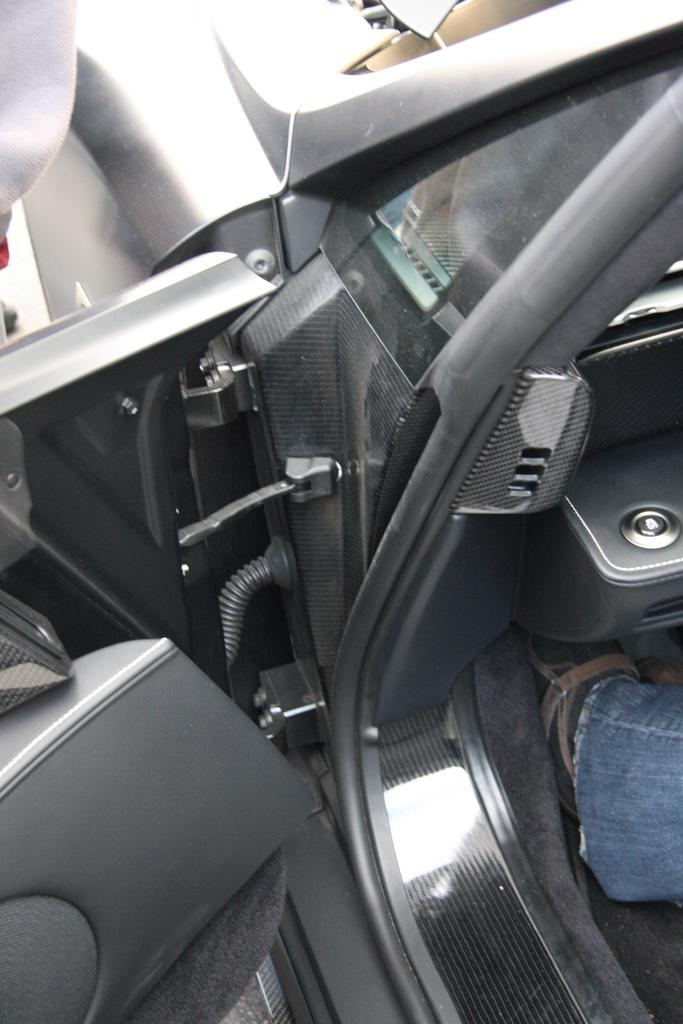What is the position of the car door in the image? The car door is opened in the image. Can you describe the presence of a person in the image? A person's leg is visible inside the car, and there is also a person standing on the left side of the image. What type of street is visible in the image? There is no street visible in the image; it only shows a car door and a person's leg inside the car. What fact can be determined about the car's speed from the image? The image does not provide any information about the car's speed, as it only shows the opened car door and a person's leg inside the car. 